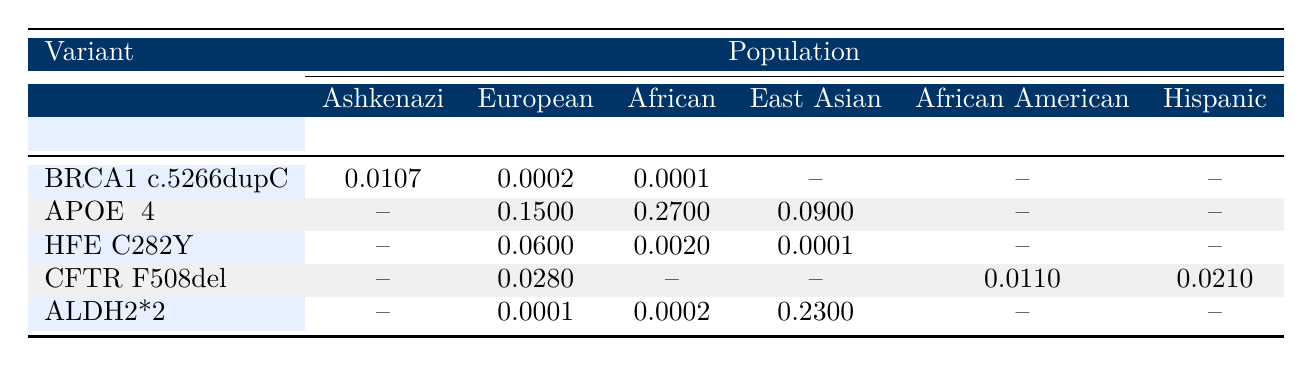What is the frequency of the BRCA1 c.5266dupC variant in the Ashkenazi Jewish population? The table shows that the frequency of the BRCA1 c.5266dupC variant in the Ashkenazi Jewish population is listed directly. By looking at the corresponding row, the value is 0.0107.
Answer: 0.0107 Which population has the highest frequency for the APOE ε4 variant? By comparing the frequencies of the APOE ε4 variant across the populations listed, the values are 0.15 for Europeans, 0.27 for Africans, and 0.09 for East Asians. The highest frequency is in the African population at 0.27.
Answer: African Is the frequency of the HFE C282Y variant higher in Europeans or in Africans? The table lists the frequency of the HFE C282Y variant as 0.06 for Europeans and 0.002 for Africans. Therefore, comparing these values shows that 0.06 (Europeans) is greater than 0.002 (Africans).
Answer: Yes What is the total frequency of CFTR F508del in all populations listed except Europeans? The table shows the frequency of CFTR F508del as 0.011 for African Americans and 0.021 for Hispanics. Summing these frequencies gives 0.011 + 0.021 = 0.032 for the populations not including Europeans.
Answer: 0.032 Can we say that the ALDH2*2 variant occurs equally across all populations? The table shows varied frequencies for the ALDH2*2 variant: 0.0001 for Europeans, 0.0002 for Africans, and 0.23 for East Asians. Since these values are not the same, we conclude that the occurrence is not equal across populations.
Answer: No What is the average frequency of the BRCA1 c.5266dupC, APOE ε4, and HFE C282Y variants in the African population? The frequencies in the African population are 0.0001 for BRCA1 c.5266dupC, 0.27 for APOE ε4, and 0.002 for HFE C282Y. The average is calculated by summing the frequencies (0.0001 + 0.27 + 0.002) = 0.2721 and dividing by the number of data points (3), which results in approximately 0.0907.
Answer: 0.0907 Do any populations not show a frequency for the CFTR F508del variant? Looking at the CFTR F508del row, the population categories listed show frequency values for African Americans (0.011) and Hispanics (0.021), but it has no frequency reported for Africans and East Asians, hence there are populations without a frequency.
Answer: Yes Which variant is associated with the highest study size in the European population? The study sizes associated with each variant in the European population are as follows: BRCA1 c.5266dupC (12000), APOE ε4 (25000), HFE C282Y (20000), and CFTR F508del (30000). The highest study size is for the CFTR F508del variant at 30000.
Answer: CFTR F508del 